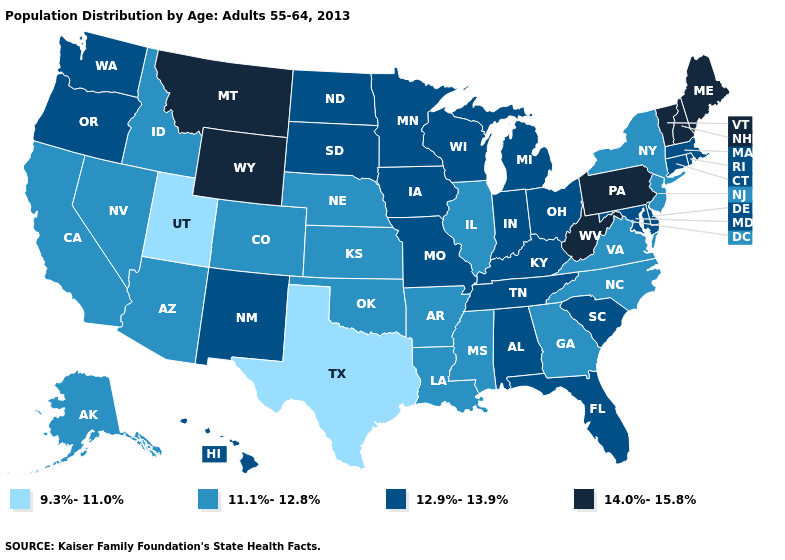Does the map have missing data?
Be succinct. No. Name the states that have a value in the range 14.0%-15.8%?
Quick response, please. Maine, Montana, New Hampshire, Pennsylvania, Vermont, West Virginia, Wyoming. Does California have the highest value in the West?
Keep it brief. No. Does the first symbol in the legend represent the smallest category?
Quick response, please. Yes. What is the value of South Carolina?
Quick response, please. 12.9%-13.9%. Name the states that have a value in the range 12.9%-13.9%?
Write a very short answer. Alabama, Connecticut, Delaware, Florida, Hawaii, Indiana, Iowa, Kentucky, Maryland, Massachusetts, Michigan, Minnesota, Missouri, New Mexico, North Dakota, Ohio, Oregon, Rhode Island, South Carolina, South Dakota, Tennessee, Washington, Wisconsin. What is the lowest value in states that border Minnesota?
Keep it brief. 12.9%-13.9%. Does New Jersey have the lowest value in the Northeast?
Quick response, please. Yes. What is the value of Louisiana?
Give a very brief answer. 11.1%-12.8%. Which states have the lowest value in the West?
Be succinct. Utah. What is the lowest value in states that border Iowa?
Quick response, please. 11.1%-12.8%. Among the states that border New Hampshire , does Vermont have the lowest value?
Quick response, please. No. Name the states that have a value in the range 11.1%-12.8%?
Be succinct. Alaska, Arizona, Arkansas, California, Colorado, Georgia, Idaho, Illinois, Kansas, Louisiana, Mississippi, Nebraska, Nevada, New Jersey, New York, North Carolina, Oklahoma, Virginia. Does Pennsylvania have the same value as North Carolina?
Give a very brief answer. No. 